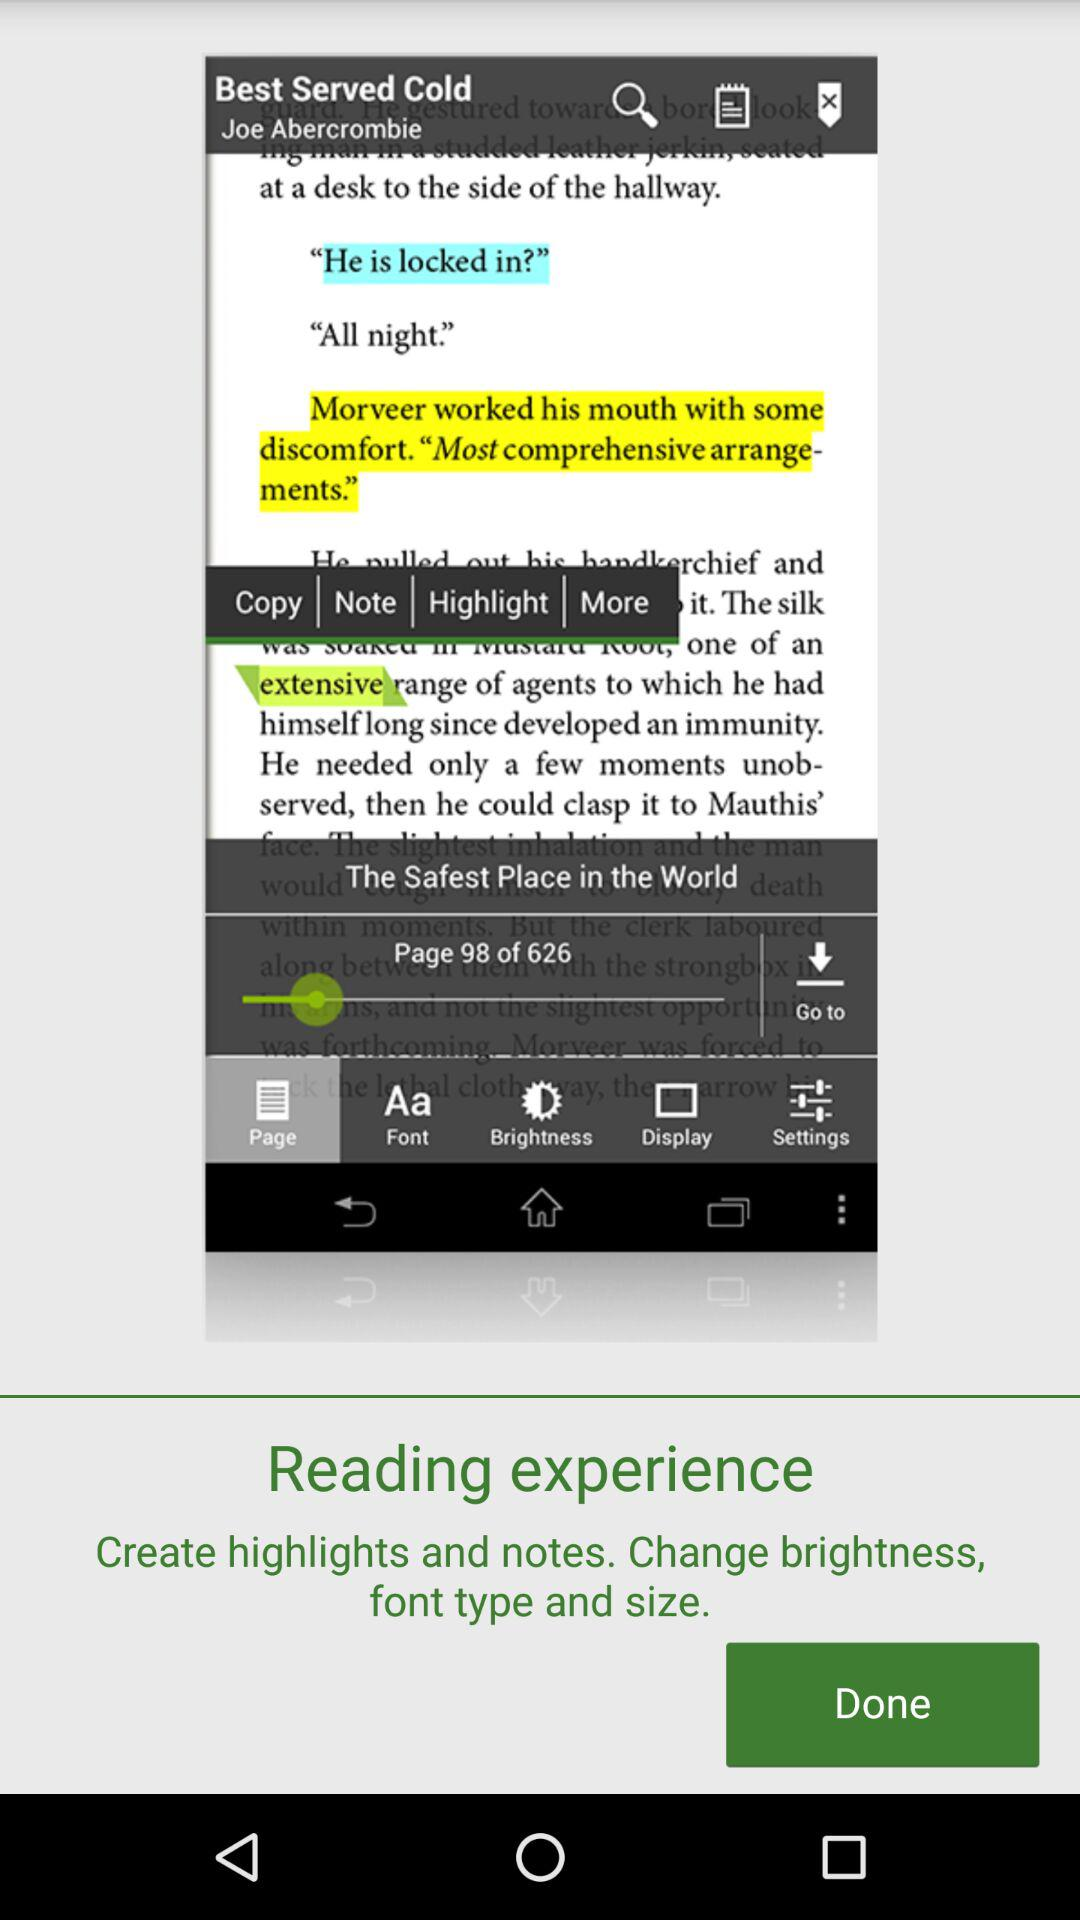How many pages in total are there? There are 626 pages. 